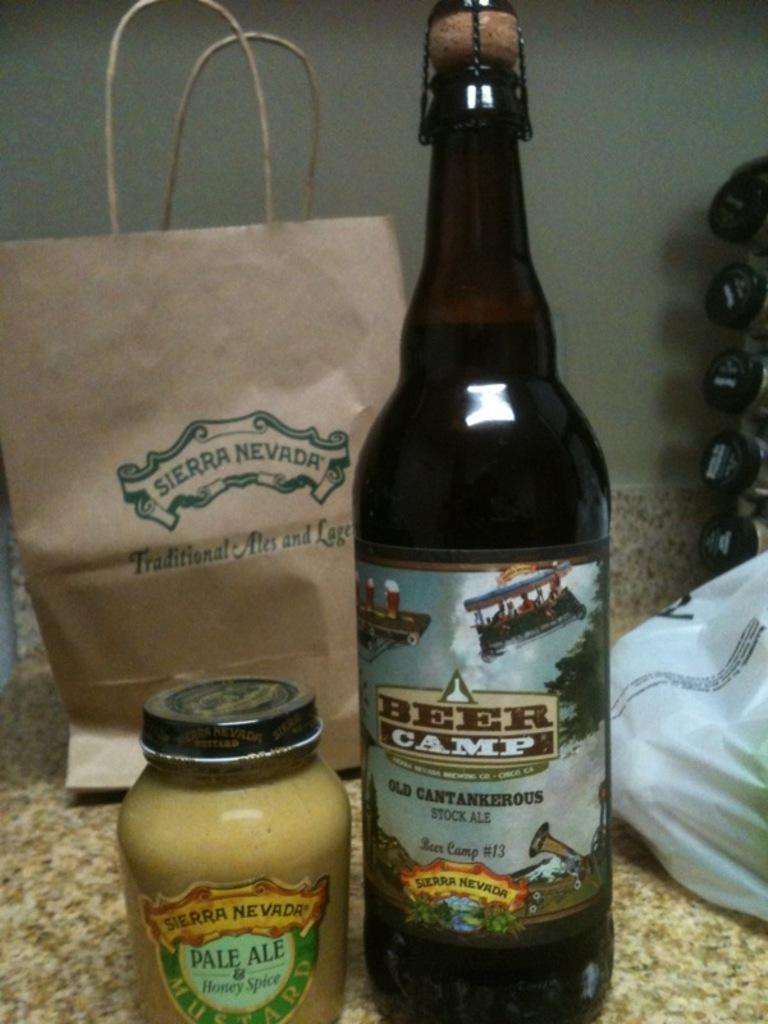What type of container is in the middle of the image? There is a beer bottle and a glass jar in the middle of the image. What else can be seen in the image besides the beer bottle and glass jar? There is a bag on the right side of the image. What type of bell can be heard ringing in the image? There is no bell present in the image, and therefore no sound can be heard. 